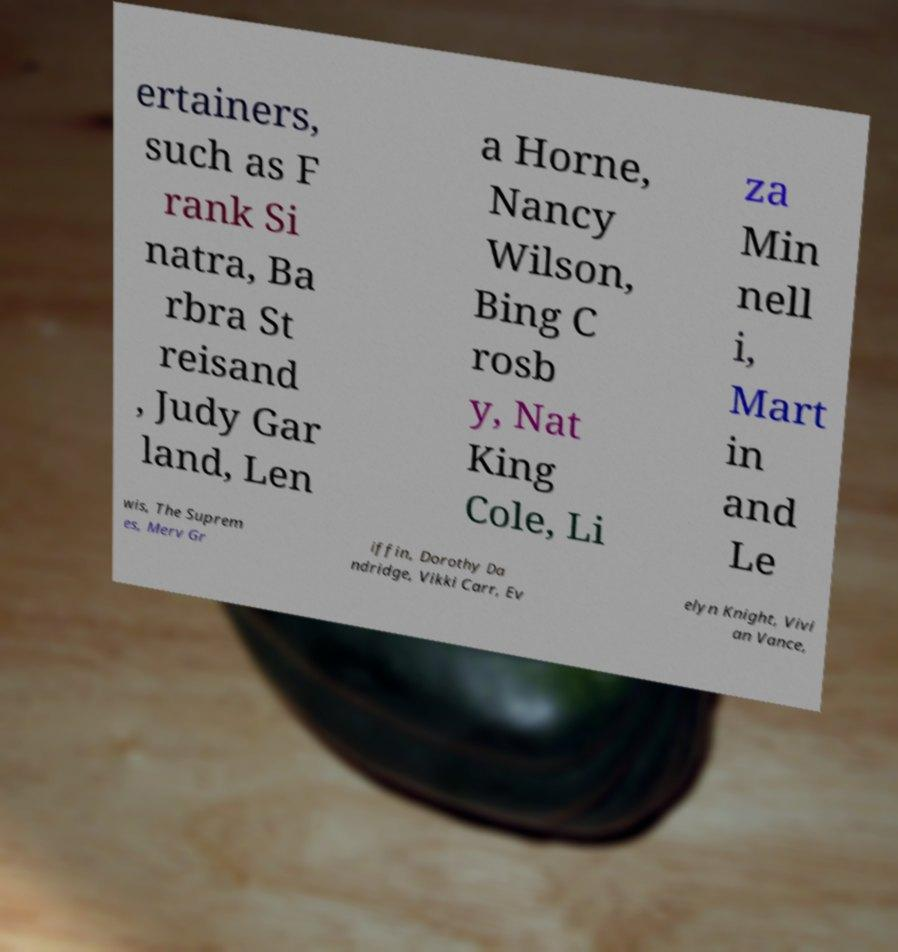There's text embedded in this image that I need extracted. Can you transcribe it verbatim? ertainers, such as F rank Si natra, Ba rbra St reisand , Judy Gar land, Len a Horne, Nancy Wilson, Bing C rosb y, Nat King Cole, Li za Min nell i, Mart in and Le wis, The Suprem es, Merv Gr iffin, Dorothy Da ndridge, Vikki Carr, Ev elyn Knight, Vivi an Vance, 